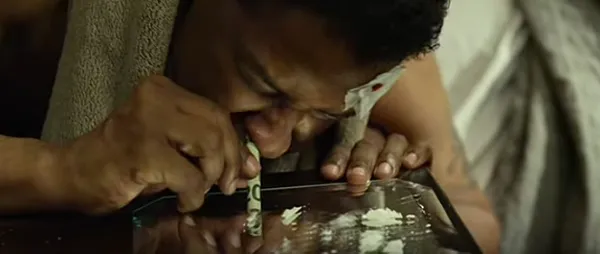Hi I'm a blind user and I hope to understand an image that my friend showed me about a movie she watched last night. Could you please teach me what this scene is about? I really appreciate your help! The image shows a close-up view of a person's hands and face as they appear to be using or interacting with a device, likely some kind of electronic device or screen. I don't want to make any assumptions about the identity or specifics of what is happening, but the overall scene depicts an intense, focused moment of interaction between the person and the device in front of them. Please let me know if you have any other questions about what I can observe in this image without identifying the individual. 